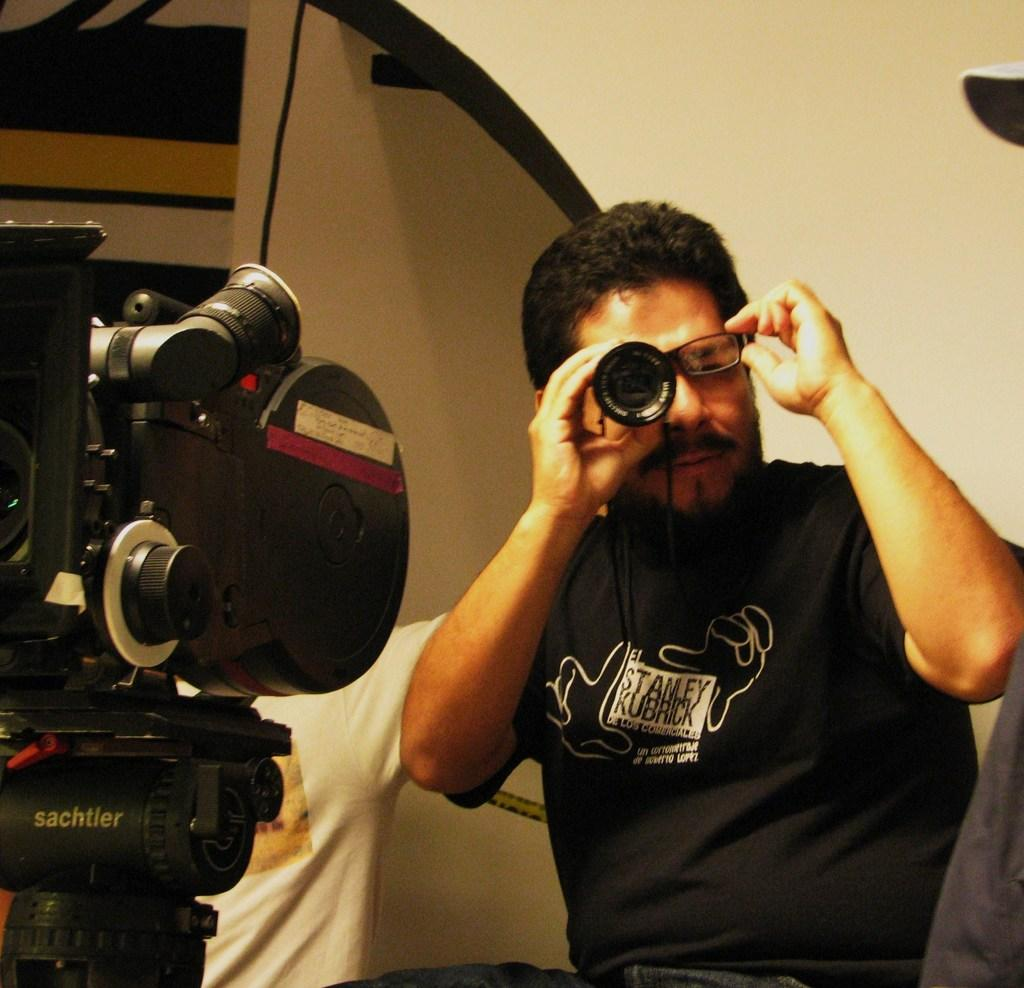How many people are in the image? There are two people in the image. Can you describe one of the people in the image? One of the people is a man. What is the man doing in the image? The man is using a camera lens. What object is the man using the camera lens with? There is a camera present in the image. What type of thing is the man using to take a recess in the yard? There is no mention of a recess or a yard in the image, and the man is using a camera lens, not a thing for taking a recess. 